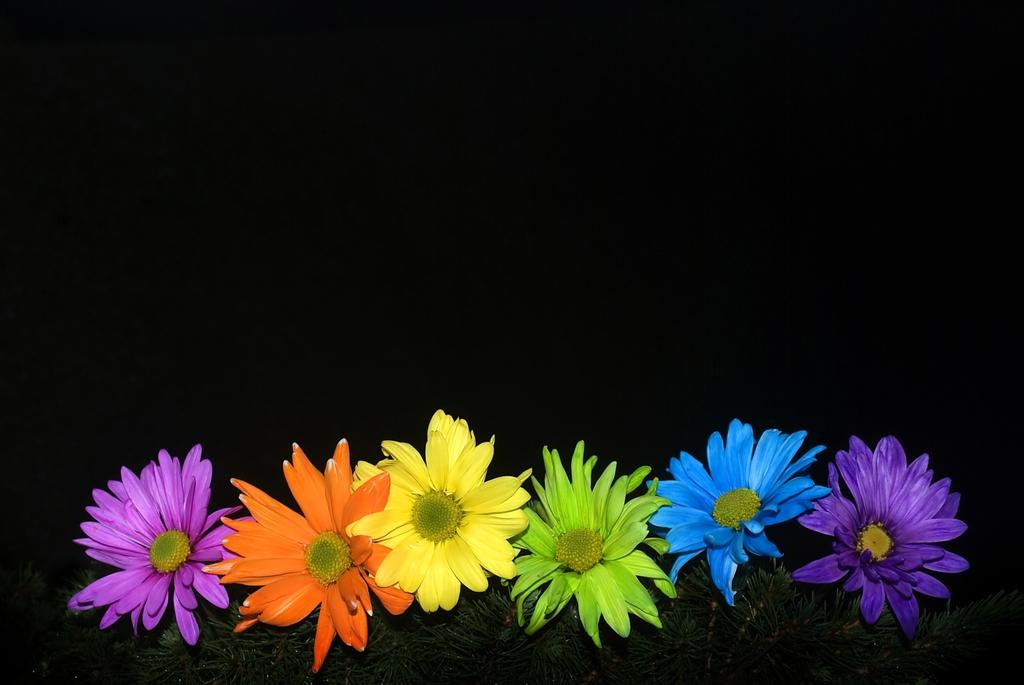What type of plants are at the bottom of the image? There are colorful flowers at the bottom of the image. What else can be seen under the flowers? There are leaves visible under the flowers. What color is the background of the image? The background of the image is black. What type of rock is being served by the servant in the image? There is no rock or servant present in the image. 